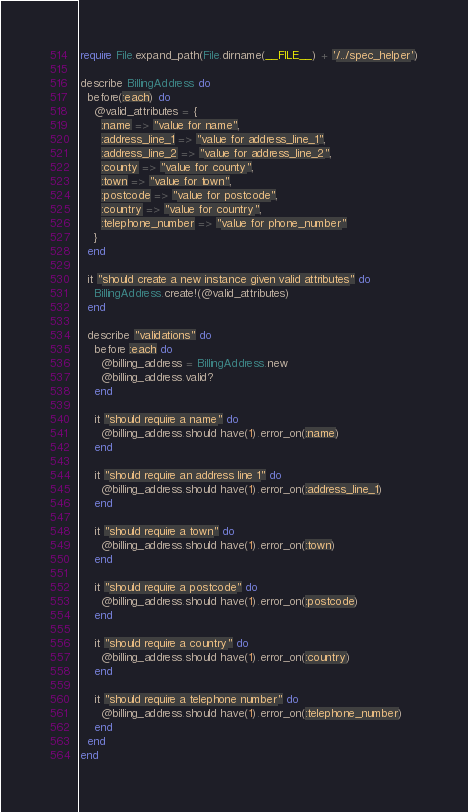Convert code to text. <code><loc_0><loc_0><loc_500><loc_500><_Ruby_>require File.expand_path(File.dirname(__FILE__) + '/../spec_helper')

describe BillingAddress do
  before(:each) do
    @valid_attributes = {
      :name => "value for name",
      :address_line_1 => "value for address_line_1",
      :address_line_2 => "value for address_line_2",
      :county => "value for county",
      :town => "value for town",
      :postcode => "value for postcode",
      :country => "value for country",
      :telephone_number => "value for phone_number"
    }
  end

  it "should create a new instance given valid attributes" do
    BillingAddress.create!(@valid_attributes)
  end

  describe "validations" do
    before :each do
      @billing_address = BillingAddress.new
      @billing_address.valid?
    end

    it "should require a name" do
      @billing_address.should have(1).error_on(:name)
    end
    
    it "should require an address line 1" do
      @billing_address.should have(1).error_on(:address_line_1)
    end

    it "should require a town" do
      @billing_address.should have(1).error_on(:town)
    end

    it "should require a postcode" do
      @billing_address.should have(1).error_on(:postcode)
    end

    it "should require a country" do
      @billing_address.should have(1).error_on(:country)
    end

    it "should require a telephone number" do
      @billing_address.should have(1).error_on(:telephone_number)
    end
  end
end
</code> 